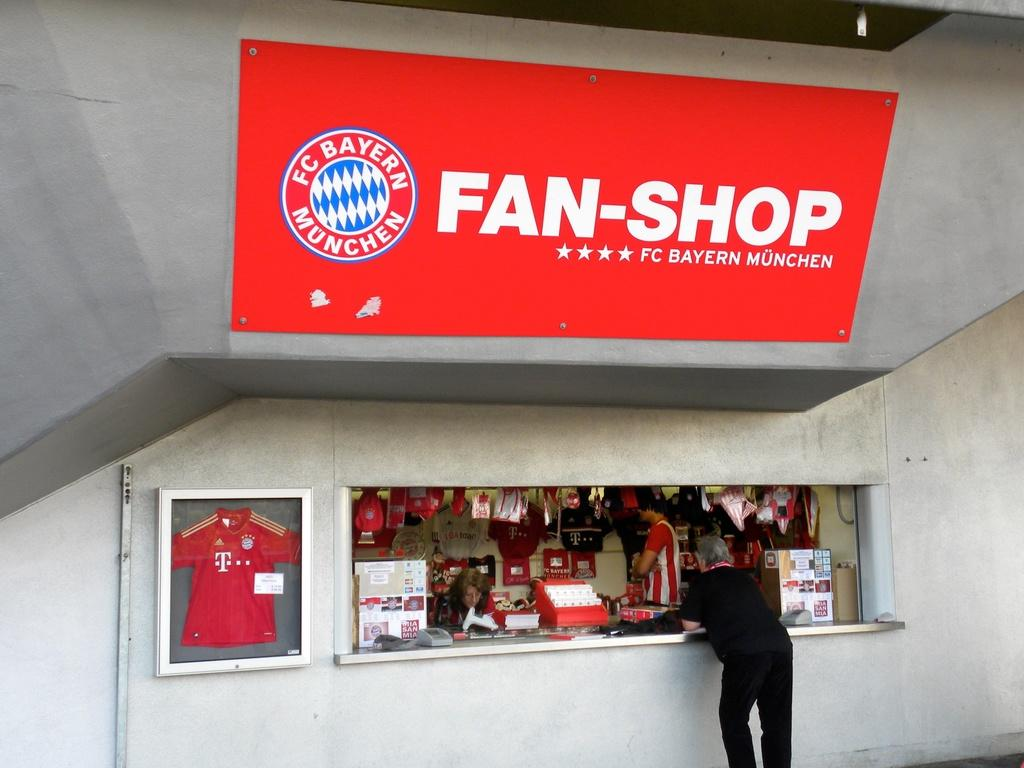<image>
Summarize the visual content of the image. The Fan shop of the FC Bayern Munchen team 